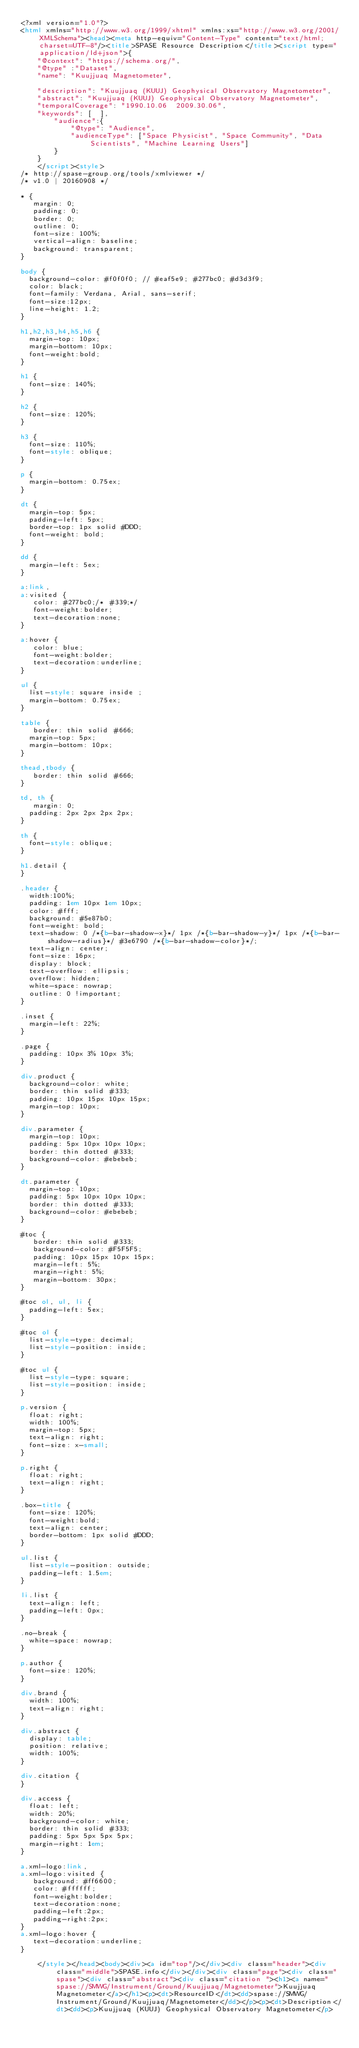<code> <loc_0><loc_0><loc_500><loc_500><_HTML_><?xml version="1.0"?>
<html xmlns="http://www.w3.org/1999/xhtml" xmlns:xs="http://www.w3.org/2001/XMLSchema"><head><meta http-equiv="Content-Type" content="text/html; charset=UTF-8"/><title>SPASE Resource Description</title><script type="application/ld+json">{
		"@context": "https://schema.org/",
		"@type" :"Dataset",
		"name": "Kuujjuaq Magnetometer",
     
 		"description": "Kuujjuaq (KUUJ) Geophysical Observatory Magnetometer",
		"abstract": "Kuujjuaq (KUUJ) Geophysical Observatory Magnetometer",
		"temporalCoverage": "1990.10.06  2009.30.06",
		"keywords": [  ],
        "audience":{
            "@type": "Audience",
            "audienceType": ["Space Physicist", "Space Community", "Data Scientists", "Machine Learning Users"]
        }
	  }
	  </script><style>
/* http://spase-group.org/tools/xmlviewer */
/* v1.0 | 20160908 */

* {
   margin: 0;
   padding: 0;
   border: 0;
   outline: 0;
   font-size: 100%;
   vertical-align: baseline;
   background: transparent;
}

body {
	background-color: #f0f0f0; // #eaf5e9; #277bc0; #d3d3f9;
	color: black;
	font-family: Verdana, Arial, sans-serif; 
	font-size:12px; 
	line-height: 1.2;
}
 
h1,h2,h3,h4,h5,h6 {
	margin-top: 10px;
	margin-bottom: 10px;
	font-weight:bold;
}

h1 {
	font-size: 140%;
}

h2 {
	font-size: 120%;
}

h3 {
	font-size: 110%;
	font-style: oblique;
}

p {
	margin-bottom: 0.75ex;
}

dt {
	margin-top: 5px;
	padding-left: 5px;
	border-top: 1px solid #DDD;
	font-weight: bold;
}

dd {
	margin-left: 5ex;
}

a:link,
a:visited {
   color: #277bc0;/* #339;*/
   font-weight:bolder; 
   text-decoration:none; 
}

a:hover {
   color: blue;
   font-weight:bolder; 
   text-decoration:underline; 
}

ul {
	list-style: square inside ;
	margin-bottom: 0.75ex;
}

table {
   border: thin solid #666;
	margin-top: 5px;
	margin-bottom: 10px;
}

thead,tbody {
   border: thin solid #666;
}

td, th {
   margin: 0;
	padding: 2px 2px 2px 2px;
}

th {
	font-style: oblique;
}

h1.detail {
}

.header {
	width:100%;
	padding: 1em 10px 1em 10px;
	color: #fff;
	background: #5e87b0;
	font-weight: bold;
	text-shadow: 0 /*{b-bar-shadow-x}*/ 1px /*{b-bar-shadow-y}*/ 1px /*{b-bar-shadow-radius}*/ #3e6790 /*{b-bar-shadow-color}*/;
	text-align: center;
	font-size: 16px;
	display: block;
	text-overflow: ellipsis;
	overflow: hidden;
	white-space: nowrap;
	outline: 0 !important;
}

.inset {
	margin-left: 22%;
}

.page {
	padding: 10px 3% 10px 3%;
}

div.product {
	background-color: white;
	border: thin solid #333;
	padding: 10px 15px 10px 15px;
	margin-top: 10px;
}

div.parameter {
	margin-top: 10px;
	padding: 5px 10px 10px 10px;
	border: thin dotted #333;
	background-color: #ebebeb;
}

dt.parameter {
	margin-top: 10px;
	padding: 5px 10px 10px 10px;
	border: thin dotted #333;
	background-color: #ebebeb;
}

#toc {
   border: thin solid #333;
   background-color: #F5F5F5; 
   padding: 10px 15px 10px 15px;
   margin-left: 5%;
   margin-right: 5%;
   margin-bottom: 30px;
}

#toc ol, ul, li {
	padding-left: 5ex;
}

#toc ol {
	list-style-type: decimal;
	list-style-position: inside; 
}

#toc ul {
	list-style-type: square;
	list-style-position: inside; 
}

p.version {
  float: right;
  width: 100%;
  margin-top: 5px;
  text-align: right;
  font-size: x-small;
}

p.right {
  float: right;
  text-align: right;
}

.box-title {
	font-size: 120%;
	font-weight:bold;
	text-align: center;
	border-bottom: 1px solid #DDD;
}

ul.list {
	list-style-position: outside;
	padding-left: 1.5em;
}

li.list {
	text-align: left;
	padding-left: 0px;
}

.no-break {
	white-space: nowrap;
}

p.author {
	font-size: 120%;
}

div.brand {
	width: 100%;
	text-align: right;
}

div.abstract {
	display: table;
	position: relative;
	width: 100%;
}

div.citation {
}

div.access {
	float: left;
	width: 20%;
	background-color: white;
	border: thin solid #333;
	padding: 5px 5px 5px 5px;
	margin-right: 1em;
}

a.xml-logo:link,
a.xml-logo:visited {
   background: #ff6600;
   color: #ffffff;
   font-weight:bolder; 
   text-decoration:none; 
   padding-left:2px;
   padding-right:2px;
}
a.xml-logo:hover {
   text-decoration:underline; 
}

	  </style></head><body><div><a id="top"/></div><div class="header"><div class="middle">SPASE.info</div></div><div class="page"><div class="spase"><div class="abstract"><div class="citation "><h1><a name="spase://SMWG/Instrument/Ground/Kuujjuaq/Magnetometer">Kuujjuaq Magnetometer</a></h1><p><dt>ResourceID</dt><dd>spase://SMWG/Instrument/Ground/Kuujjuaq/Magnetometer</dd></p><p><dt>Description</dt><dd><p>Kuujjuaq (KUUJ) Geophysical Observatory Magnetometer</p></code> 